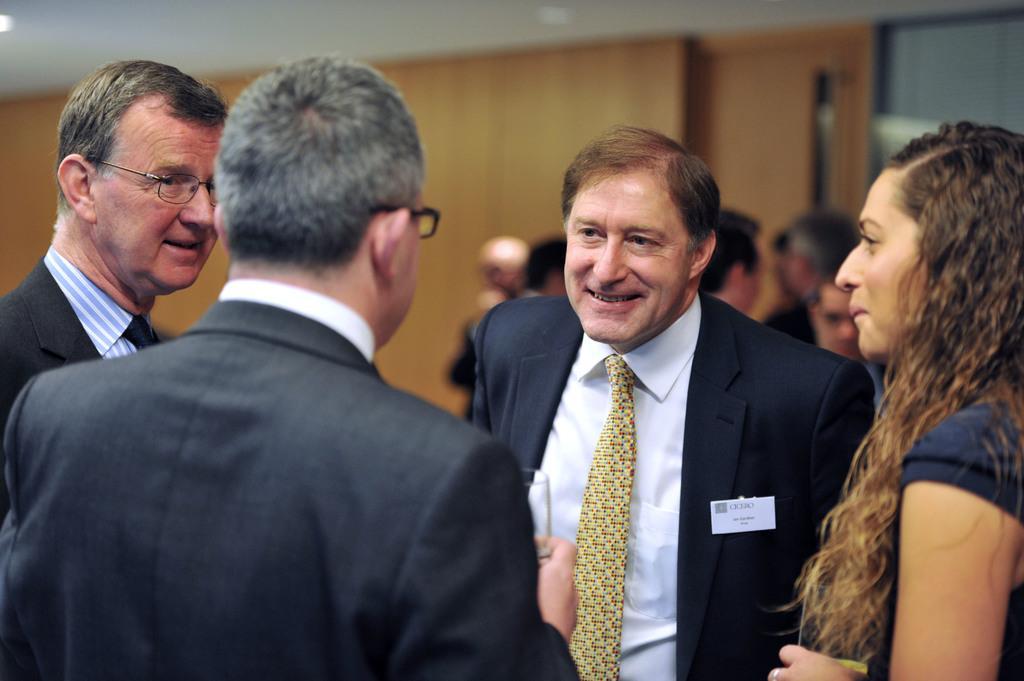Please provide a concise description of this image. In this image, I can see groups of people standing. In the background, there is a wall. At the top of the image, I can see the ceiling. 